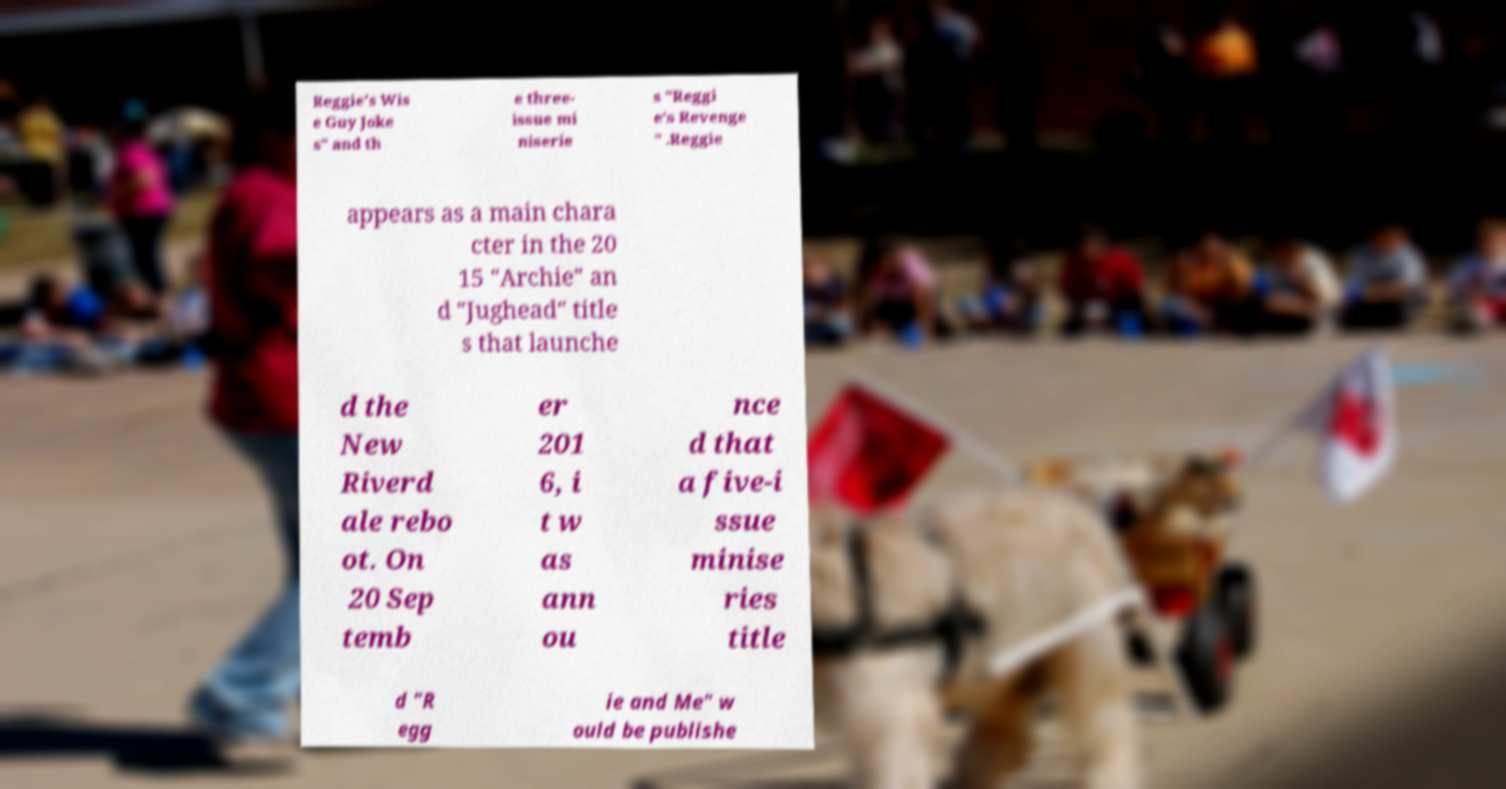Please identify and transcribe the text found in this image. Reggie's Wis e Guy Joke s" and th e three- issue mi niserie s "Reggi e's Revenge " .Reggie appears as a main chara cter in the 20 15 "Archie" an d "Jughead" title s that launche d the New Riverd ale rebo ot. On 20 Sep temb er 201 6, i t w as ann ou nce d that a five-i ssue minise ries title d "R egg ie and Me" w ould be publishe 